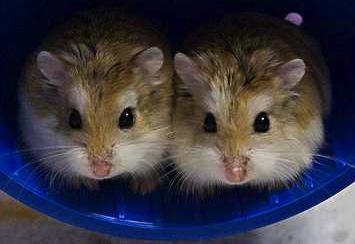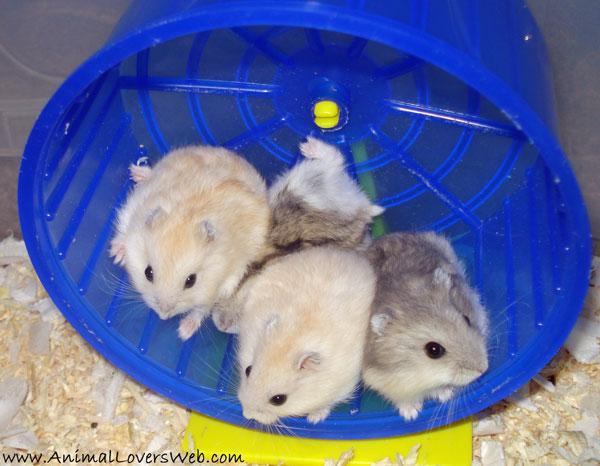The first image is the image on the left, the second image is the image on the right. Considering the images on both sides, is "Each image shows exactly two rodents." valid? Answer yes or no. No. The first image is the image on the left, the second image is the image on the right. Evaluate the accuracy of this statement regarding the images: "Every hamster is inside a wheel, and every hamster wheel is bright blue.". Is it true? Answer yes or no. Yes. 